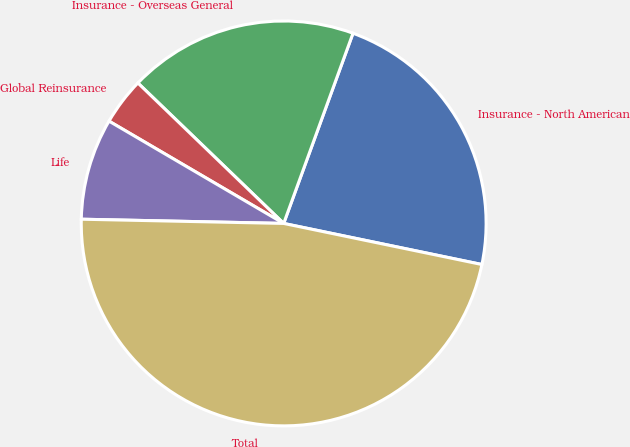Convert chart. <chart><loc_0><loc_0><loc_500><loc_500><pie_chart><fcel>Insurance - North American<fcel>Insurance - Overseas General<fcel>Global Reinsurance<fcel>Life<fcel>Total<nl><fcel>22.69%<fcel>18.36%<fcel>3.77%<fcel>8.1%<fcel>47.08%<nl></chart> 